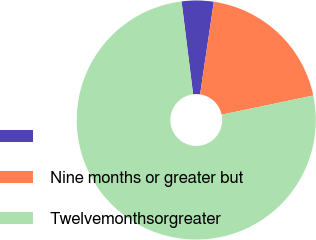Convert chart. <chart><loc_0><loc_0><loc_500><loc_500><pie_chart><ecel><fcel>Nine months or greater but<fcel>Twelvemonthsorgreater<nl><fcel>4.31%<fcel>19.37%<fcel>76.31%<nl></chart> 